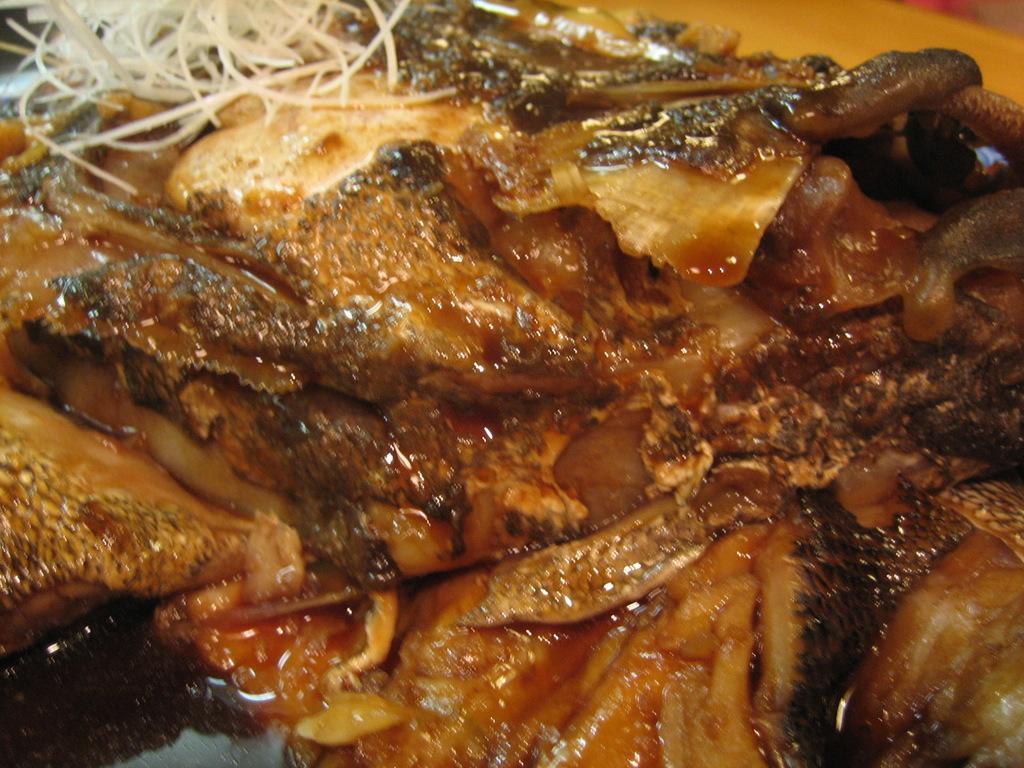Please provide a concise description of this image. In this picture i can see the fish pieces in the oil. At top there are onion pieces. In the top right corner i can see the table. 